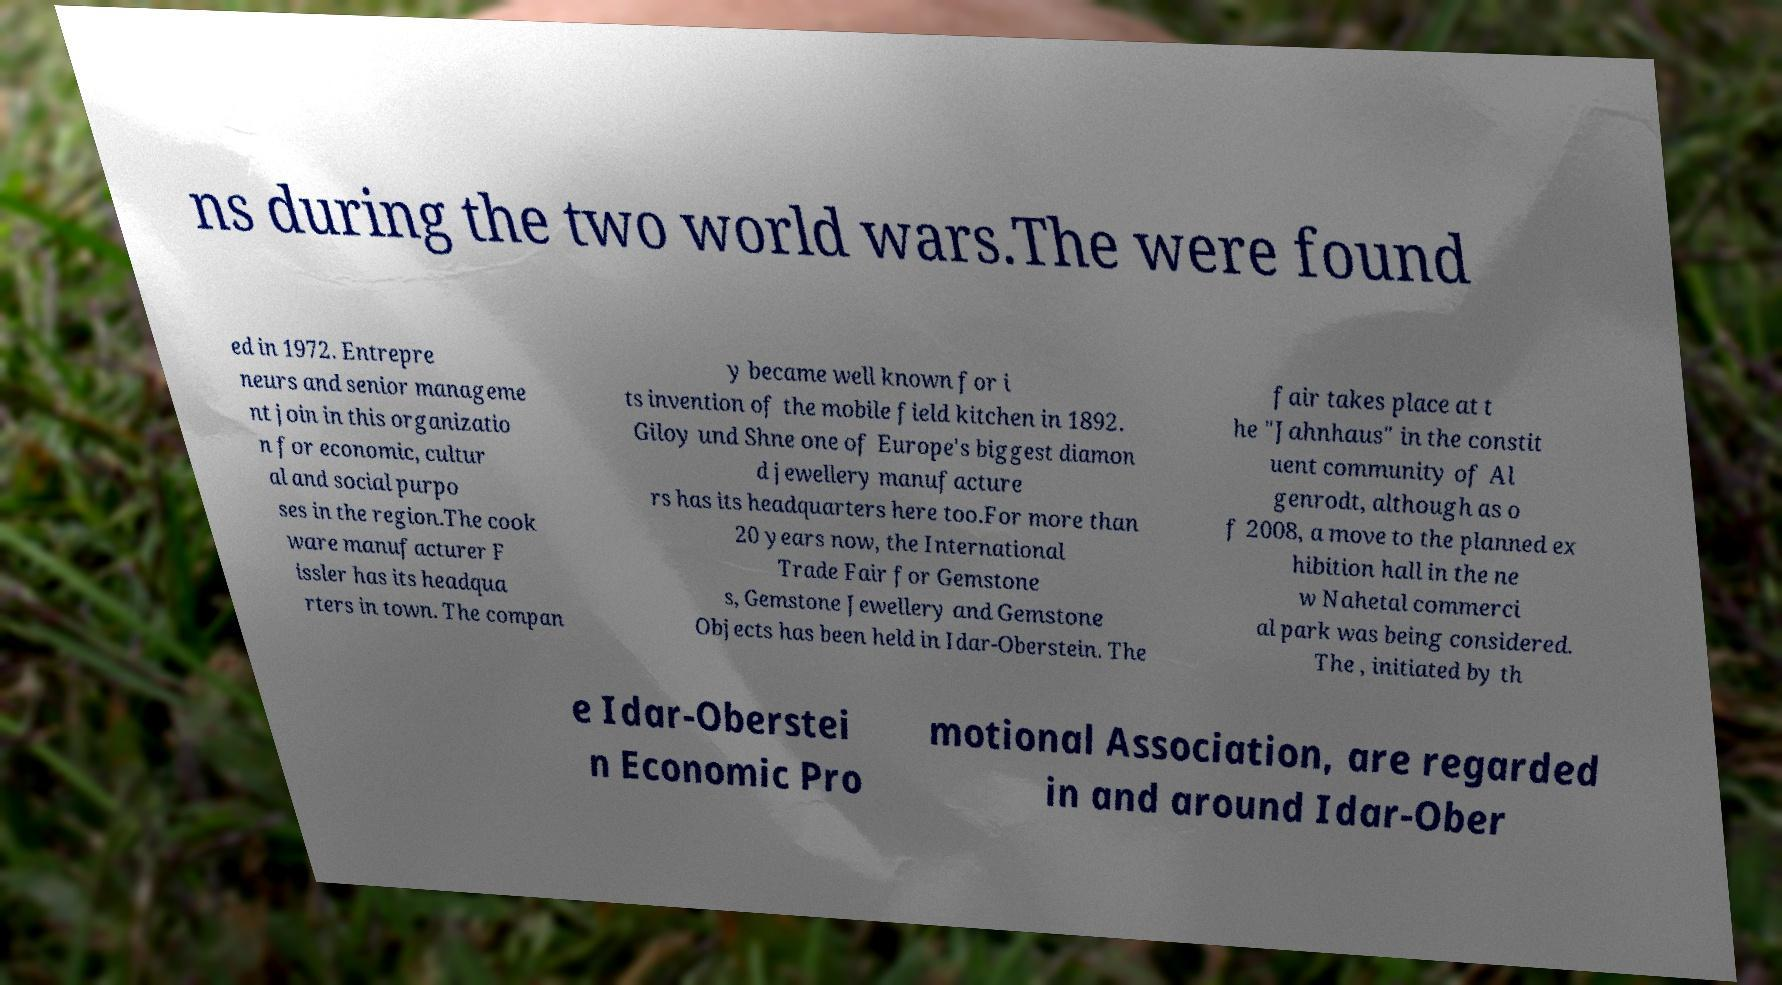Could you extract and type out the text from this image? ns during the two world wars.The were found ed in 1972. Entrepre neurs and senior manageme nt join in this organizatio n for economic, cultur al and social purpo ses in the region.The cook ware manufacturer F issler has its headqua rters in town. The compan y became well known for i ts invention of the mobile field kitchen in 1892. Giloy und Shne one of Europe's biggest diamon d jewellery manufacture rs has its headquarters here too.For more than 20 years now, the International Trade Fair for Gemstone s, Gemstone Jewellery and Gemstone Objects has been held in Idar-Oberstein. The fair takes place at t he "Jahnhaus" in the constit uent community of Al genrodt, although as o f 2008, a move to the planned ex hibition hall in the ne w Nahetal commerci al park was being considered. The , initiated by th e Idar-Oberstei n Economic Pro motional Association, are regarded in and around Idar-Ober 